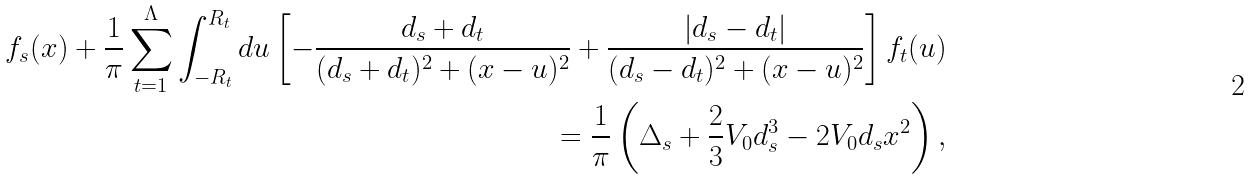Convert formula to latex. <formula><loc_0><loc_0><loc_500><loc_500>f _ { s } ( x ) + \frac { 1 } { \pi } \sum _ { t = 1 } ^ { \Lambda } \int ^ { R _ { t } } _ { - R _ { t } } d u \left [ - \frac { d _ { s } + d _ { t } } { ( d _ { s } + d _ { t } ) ^ { 2 } + ( x - u ) ^ { 2 } } + \frac { | d _ { s } - d _ { t } | } { ( d _ { s } - d _ { t } ) ^ { 2 } + ( x - u ) ^ { 2 } } \right ] f _ { t } ( u ) \\ = \frac { 1 } { \pi } \left ( \Delta _ { s } + \frac { 2 } { 3 } V _ { 0 } d _ { s } ^ { 3 } - 2 V _ { 0 } d _ { s } x ^ { 2 } \right ) ,</formula> 